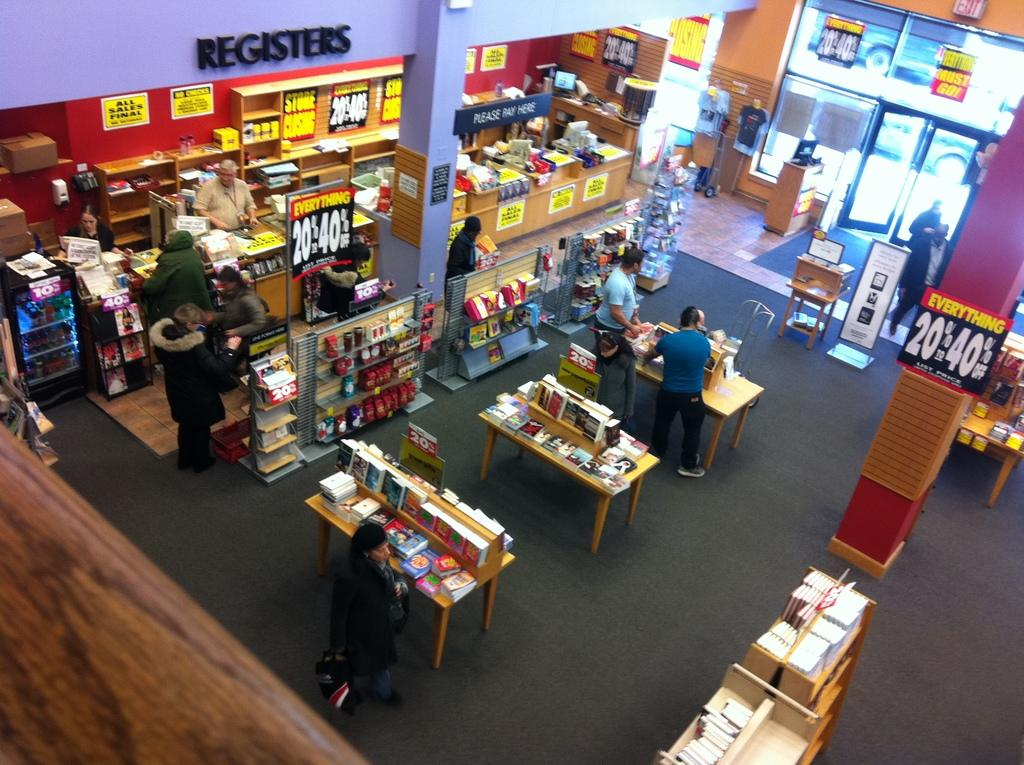<image>
Create a compact narrative representing the image presented. the inside of a store with a section specifically for registers 